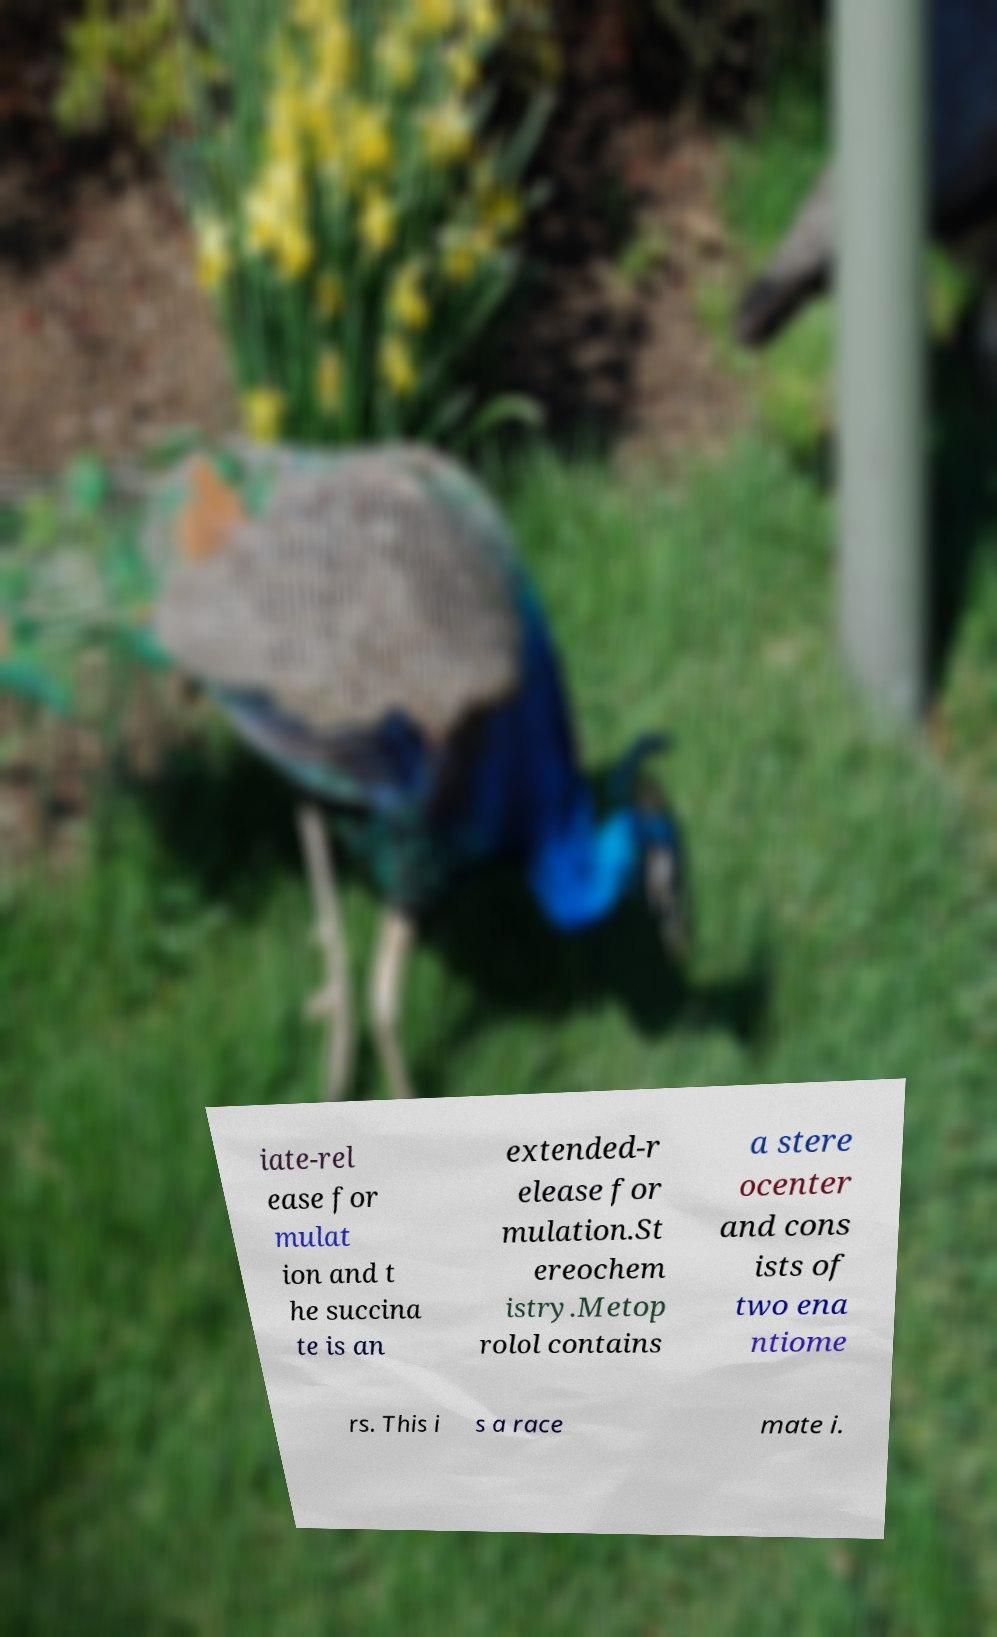Please read and relay the text visible in this image. What does it say? iate-rel ease for mulat ion and t he succina te is an extended-r elease for mulation.St ereochem istry.Metop rolol contains a stere ocenter and cons ists of two ena ntiome rs. This i s a race mate i. 